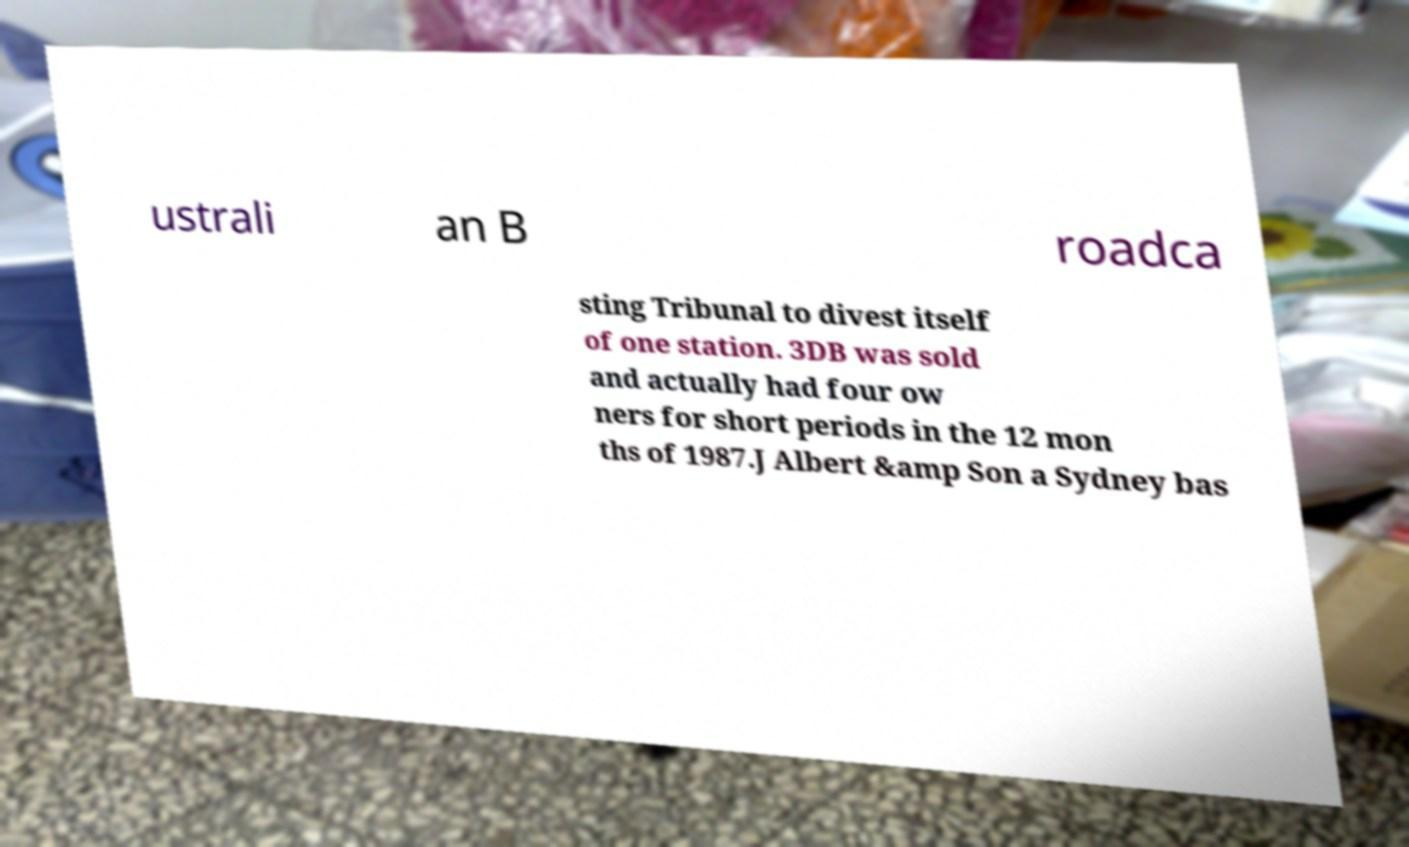Can you accurately transcribe the text from the provided image for me? ustrali an B roadca sting Tribunal to divest itself of one station. 3DB was sold and actually had four ow ners for short periods in the 12 mon ths of 1987.J Albert &amp Son a Sydney bas 